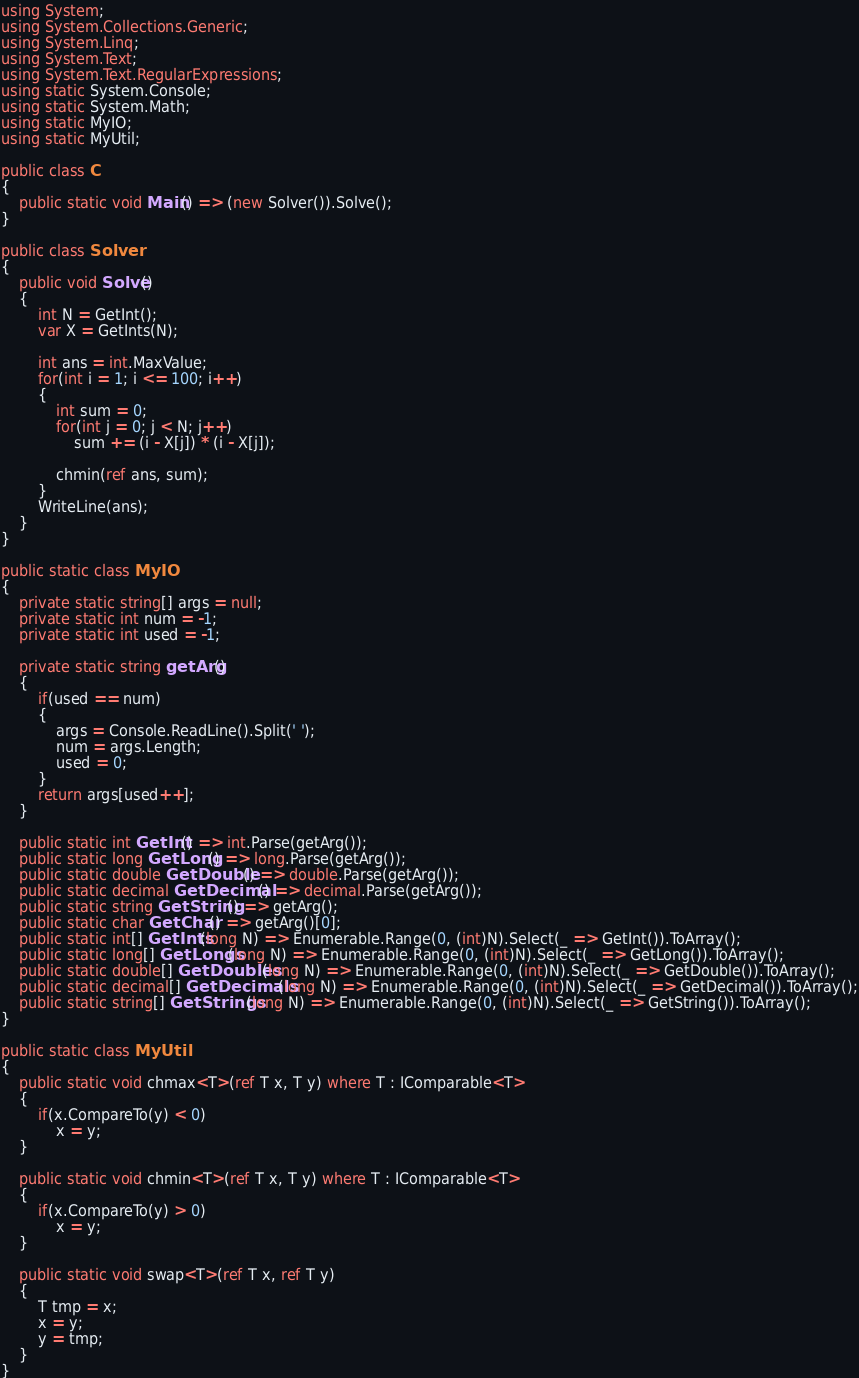Convert code to text. <code><loc_0><loc_0><loc_500><loc_500><_C#_>using System;
using System.Collections.Generic;
using System.Linq;
using System.Text;
using System.Text.RegularExpressions;
using static System.Console;
using static System.Math;
using static MyIO;
using static MyUtil;

public class C
{
	public static void Main() => (new Solver()).Solve();
}

public class Solver
{
	public void Solve()
	{
		int N = GetInt();
		var X = GetInts(N);

		int ans = int.MaxValue;
		for(int i = 1; i <= 100; i++)
		{
			int sum = 0;
			for(int j = 0; j < N; j++)
				sum += (i - X[j]) * (i - X[j]);

			chmin(ref ans, sum);
		}
		WriteLine(ans);
	}
}

public static class MyIO
{
	private static string[] args = null;
	private static int num = -1;
	private static int used = -1;

	private static string getArg()
	{
		if(used == num)
		{
			args = Console.ReadLine().Split(' ');
			num = args.Length;
			used = 0;
		}
		return args[used++];
	}

	public static int GetInt() => int.Parse(getArg());
	public static long GetLong() => long.Parse(getArg());
	public static double GetDouble() => double.Parse(getArg());
	public static decimal GetDecimal() => decimal.Parse(getArg());
	public static string GetString() => getArg();
	public static char GetChar() => getArg()[0];
	public static int[] GetInts(long N) => Enumerable.Range(0, (int)N).Select(_ => GetInt()).ToArray();
	public static long[] GetLongs(long N) => Enumerable.Range(0, (int)N).Select(_ => GetLong()).ToArray();
	public static double[] GetDoubles(long N) => Enumerable.Range(0, (int)N).Select(_ => GetDouble()).ToArray();
	public static decimal[] GetDecimals(long N) => Enumerable.Range(0, (int)N).Select(_ => GetDecimal()).ToArray();
	public static string[] GetStrings(long N) => Enumerable.Range(0, (int)N).Select(_ => GetString()).ToArray();
}

public static class MyUtil
{
	public static void chmax<T>(ref T x, T y) where T : IComparable<T>
	{
		if(x.CompareTo(y) < 0)
			x = y;
	}

	public static void chmin<T>(ref T x, T y) where T : IComparable<T>
	{
		if(x.CompareTo(y) > 0)
			x = y;
	}

	public static void swap<T>(ref T x, ref T y)
	{
		T tmp = x;
		x = y;
		y = tmp;
	}
}</code> 